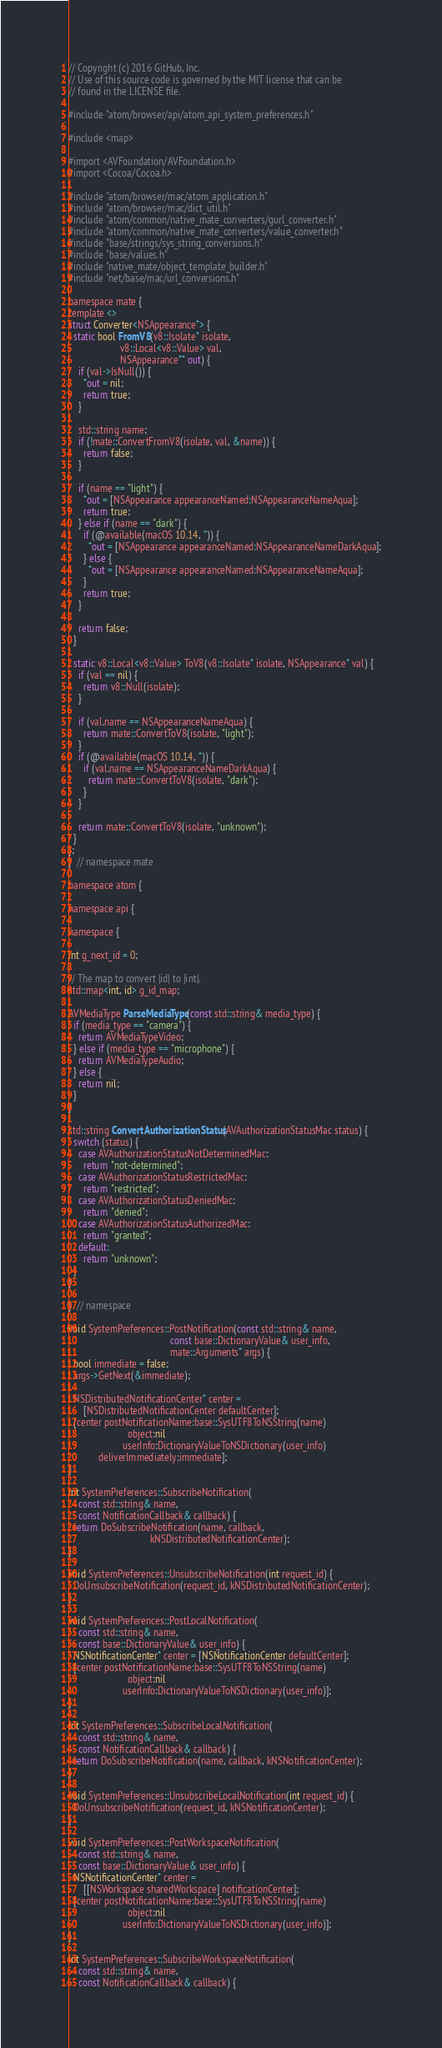<code> <loc_0><loc_0><loc_500><loc_500><_ObjectiveC_>// Copyright (c) 2016 GitHub, Inc.
// Use of this source code is governed by the MIT license that can be
// found in the LICENSE file.

#include "atom/browser/api/atom_api_system_preferences.h"

#include <map>

#import <AVFoundation/AVFoundation.h>
#import <Cocoa/Cocoa.h>

#include "atom/browser/mac/atom_application.h"
#include "atom/browser/mac/dict_util.h"
#include "atom/common/native_mate_converters/gurl_converter.h"
#include "atom/common/native_mate_converters/value_converter.h"
#include "base/strings/sys_string_conversions.h"
#include "base/values.h"
#include "native_mate/object_template_builder.h"
#include "net/base/mac/url_conversions.h"

namespace mate {
template <>
struct Converter<NSAppearance*> {
  static bool FromV8(v8::Isolate* isolate,
                     v8::Local<v8::Value> val,
                     NSAppearance** out) {
    if (val->IsNull()) {
      *out = nil;
      return true;
    }

    std::string name;
    if (!mate::ConvertFromV8(isolate, val, &name)) {
      return false;
    }

    if (name == "light") {
      *out = [NSAppearance appearanceNamed:NSAppearanceNameAqua];
      return true;
    } else if (name == "dark") {
      if (@available(macOS 10.14, *)) {
        *out = [NSAppearance appearanceNamed:NSAppearanceNameDarkAqua];
      } else {
        *out = [NSAppearance appearanceNamed:NSAppearanceNameAqua];
      }
      return true;
    }

    return false;
  }

  static v8::Local<v8::Value> ToV8(v8::Isolate* isolate, NSAppearance* val) {
    if (val == nil) {
      return v8::Null(isolate);
    }

    if (val.name == NSAppearanceNameAqua) {
      return mate::ConvertToV8(isolate, "light");
    }
    if (@available(macOS 10.14, *)) {
      if (val.name == NSAppearanceNameDarkAqua) {
        return mate::ConvertToV8(isolate, "dark");
      }
    }

    return mate::ConvertToV8(isolate, "unknown");
  }
};
}  // namespace mate

namespace atom {

namespace api {

namespace {

int g_next_id = 0;

// The map to convert |id| to |int|.
std::map<int, id> g_id_map;

AVMediaType ParseMediaType(const std::string& media_type) {
  if (media_type == "camera") {
    return AVMediaTypeVideo;
  } else if (media_type == "microphone") {
    return AVMediaTypeAudio;
  } else {
    return nil;
  }
}

std::string ConvertAuthorizationStatus(AVAuthorizationStatusMac status) {
  switch (status) {
    case AVAuthorizationStatusNotDeterminedMac:
      return "not-determined";
    case AVAuthorizationStatusRestrictedMac:
      return "restricted";
    case AVAuthorizationStatusDeniedMac:
      return "denied";
    case AVAuthorizationStatusAuthorizedMac:
      return "granted";
    default:
      return "unknown";
  }
}

}  // namespace

void SystemPreferences::PostNotification(const std::string& name,
                                         const base::DictionaryValue& user_info,
                                         mate::Arguments* args) {
  bool immediate = false;
  args->GetNext(&immediate);

  NSDistributedNotificationCenter* center =
      [NSDistributedNotificationCenter defaultCenter];
  [center postNotificationName:base::SysUTF8ToNSString(name)
                        object:nil
                      userInfo:DictionaryValueToNSDictionary(user_info)
            deliverImmediately:immediate];
}

int SystemPreferences::SubscribeNotification(
    const std::string& name,
    const NotificationCallback& callback) {
  return DoSubscribeNotification(name, callback,
                                 kNSDistributedNotificationCenter);
}

void SystemPreferences::UnsubscribeNotification(int request_id) {
  DoUnsubscribeNotification(request_id, kNSDistributedNotificationCenter);
}

void SystemPreferences::PostLocalNotification(
    const std::string& name,
    const base::DictionaryValue& user_info) {
  NSNotificationCenter* center = [NSNotificationCenter defaultCenter];
  [center postNotificationName:base::SysUTF8ToNSString(name)
                        object:nil
                      userInfo:DictionaryValueToNSDictionary(user_info)];
}

int SystemPreferences::SubscribeLocalNotification(
    const std::string& name,
    const NotificationCallback& callback) {
  return DoSubscribeNotification(name, callback, kNSNotificationCenter);
}

void SystemPreferences::UnsubscribeLocalNotification(int request_id) {
  DoUnsubscribeNotification(request_id, kNSNotificationCenter);
}

void SystemPreferences::PostWorkspaceNotification(
    const std::string& name,
    const base::DictionaryValue& user_info) {
  NSNotificationCenter* center =
      [[NSWorkspace sharedWorkspace] notificationCenter];
  [center postNotificationName:base::SysUTF8ToNSString(name)
                        object:nil
                      userInfo:DictionaryValueToNSDictionary(user_info)];
}

int SystemPreferences::SubscribeWorkspaceNotification(
    const std::string& name,
    const NotificationCallback& callback) {</code> 